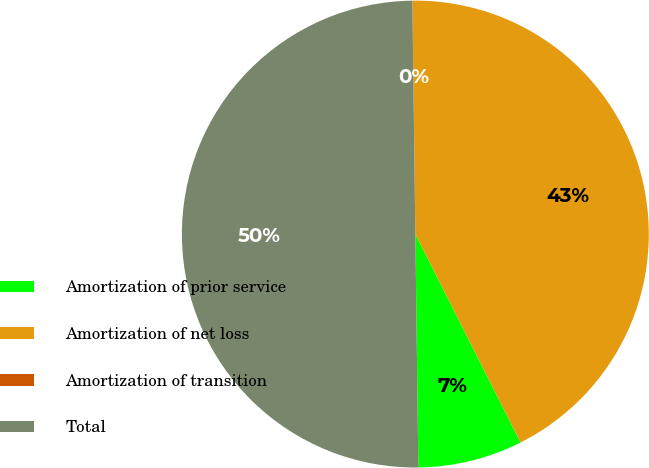Convert chart. <chart><loc_0><loc_0><loc_500><loc_500><pie_chart><fcel>Amortization of prior service<fcel>Amortization of net loss<fcel>Amortization of transition<fcel>Total<nl><fcel>7.24%<fcel>42.75%<fcel>0.01%<fcel>50.0%<nl></chart> 